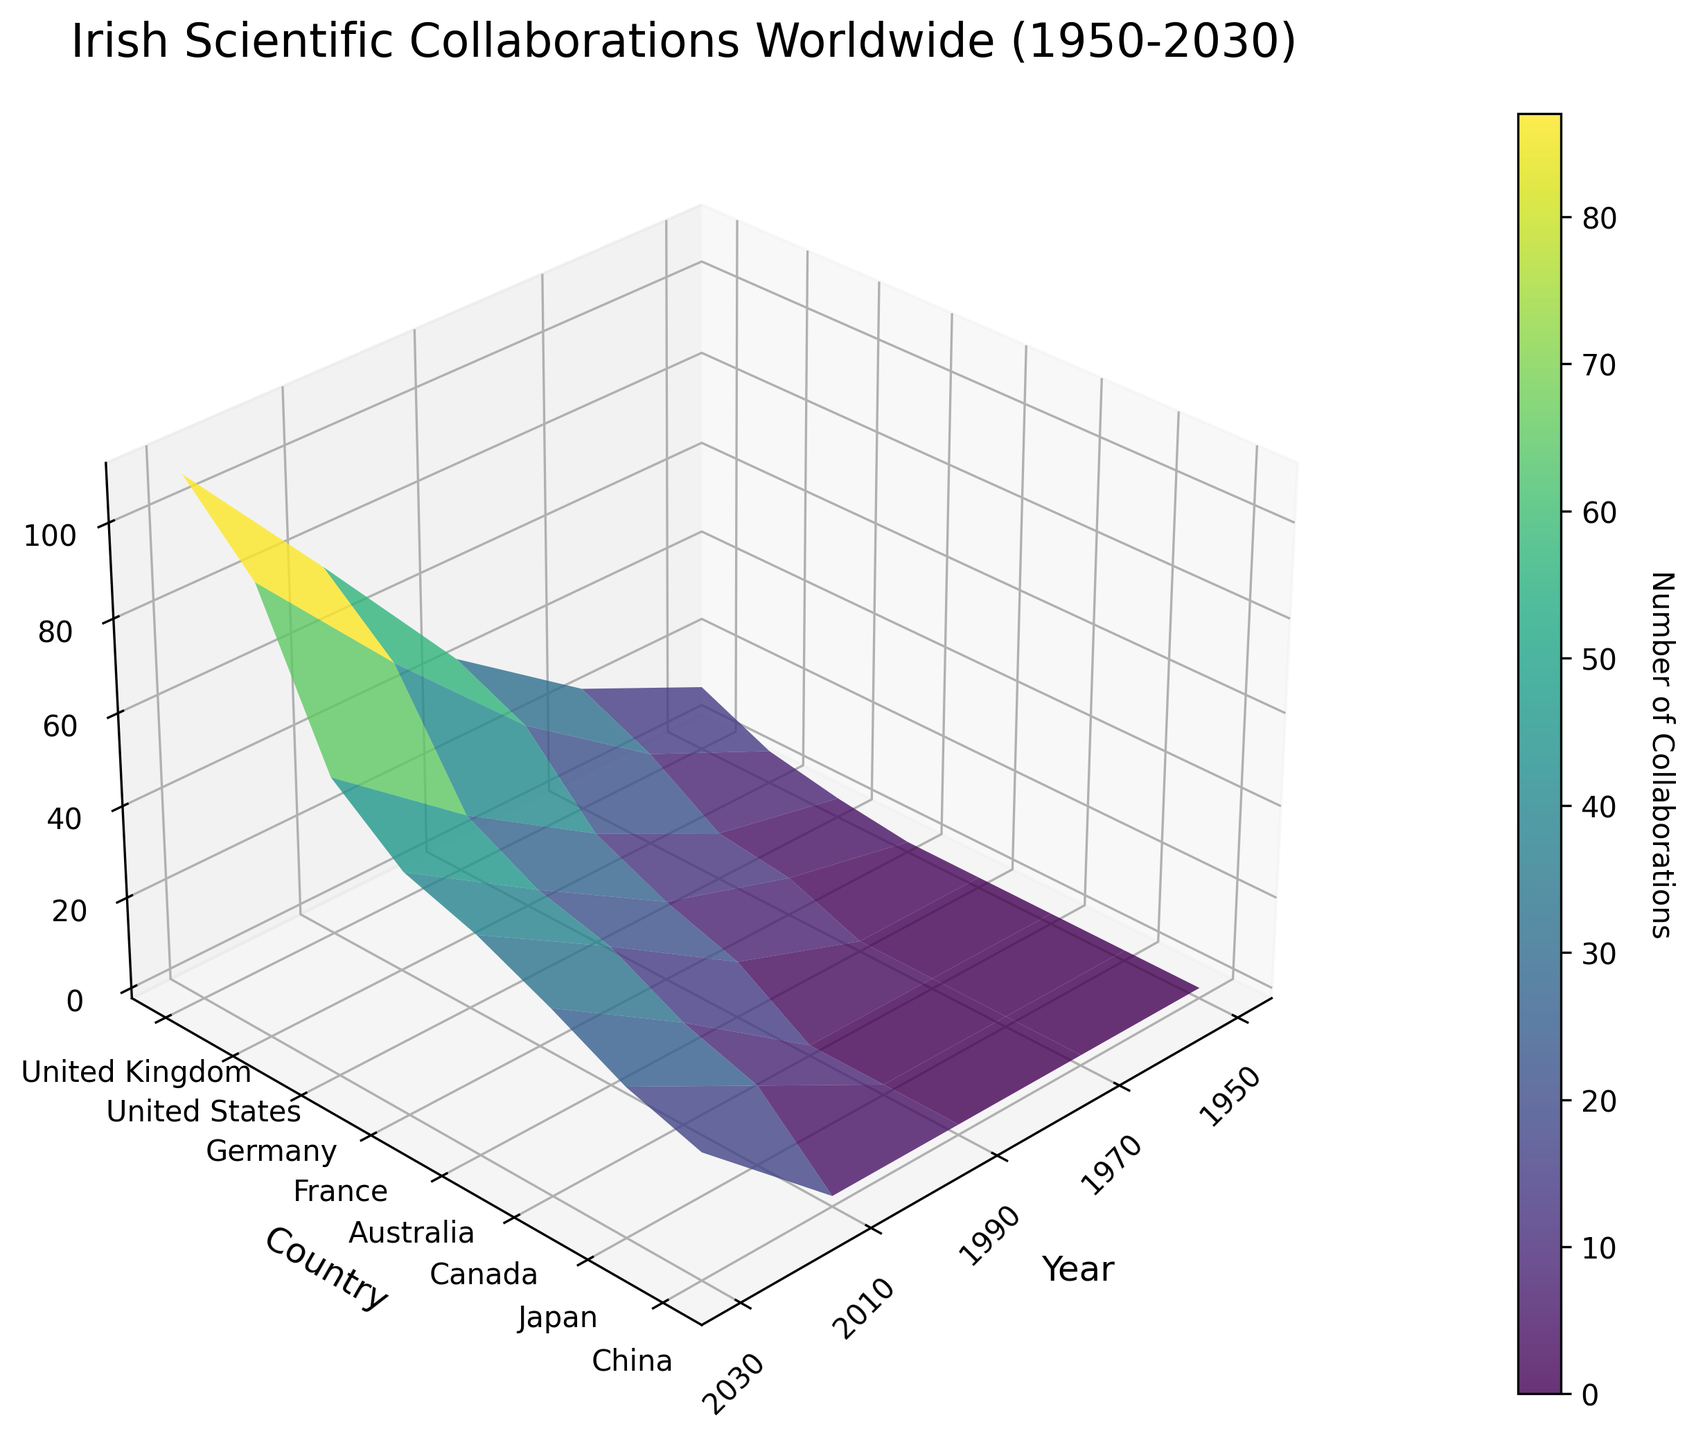What is the title of the figure? The title is located at the top of the figure, indicating the subject of the plot. It reads, "Irish Scientific Collaborations Worldwide (1950-2030)".
Answer: Irish Scientific Collaborations Worldwide (1950-2030) Which country had the most collaborations with Ireland in 1950? By inspecting the 3D surface plot for the year 1950, you can observe the highest peak corresponding to a country. The United Kingdom has the most collaborations.
Answer: United Kingdom How did the number of collaborations with the United States change from 1990 to 2010? Locate the data points for the United States for the years 1990 and 2010, then observe their z-values. The number of collaborations increased from 38 in 1990 to 65 in 2010.
Answer: Increased What countries were newly added in 2010 as collaborators with Ireland compared to 1990? Compare the list of countries in 1990 and 2010 on the y-axis. The newly added collaborators in 2010 compared to 1990 are Canada and Japan.
Answer: Canada, Japan Which year witnessed the maximum total collaborations across all countries? Summing up the z-values for all countries for each year, it's observable that 2030 has the highest total number of collaborations among all the years presented in the 3D plot.
Answer: 2030 Did collaborations with Germany increase continuously from 1950 to 2030? Follow the peak heights (z-values) associated with Germany horizontally across the years. The number steadily rises from 2 in 1950 to 62 in 2030, indicating a continuous increase.
Answer: Yes By how much did collaborations with Australia increase from 1990 to 2030? Look at the number of collaborations for Australia in 1990 and 2030. Subtract the earlier value from the latter to get the increase: 45 (in 2030) - 10 (in 1990) equals 35.
Answer: 35 Which country had the smallest number of collaborations with Ireland in 1970? Inspect the values for the year 1970 across all countries. Germany had the smallest number of collaborations, totaling 8.
Answer: Germany How many countries collaborated with Ireland in 1990? Count the distinct countries on the y-axis that have corresponding values for the year 1990. There are five: United Kingdom, United States, Germany, France, and Australia.
Answer: Five What trend do you observe about collaborations with China? Observing China on the y-axis, which is only marked in 2030, shows it newly appears and has 25 collaborations. This indicates a new presence in 2030.
Answer: New presence in 2030 